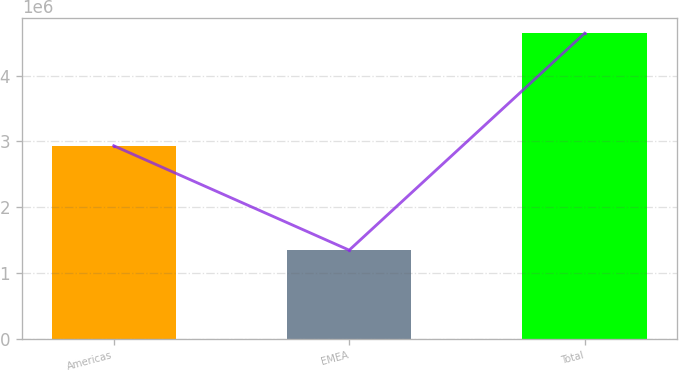Convert chart to OTSL. <chart><loc_0><loc_0><loc_500><loc_500><bar_chart><fcel>Americas<fcel>EMEA<fcel>Total<nl><fcel>2.93503e+06<fcel>1.34816e+06<fcel>4.64541e+06<nl></chart> 